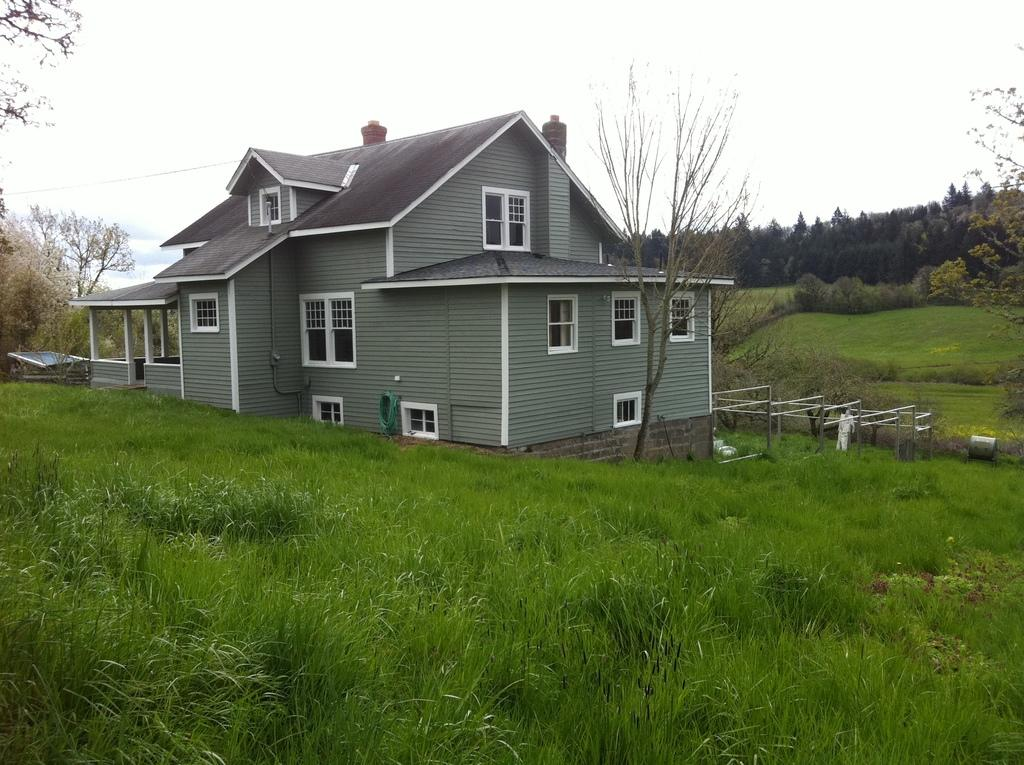What is the main structure visible in the foreground of the image? There is a house in the foreground of the image. What type of vegetation surrounds the house? There is grass around the house. What can be seen on the left side of the image? There are trees on the left side of the image. What is present on both the left and right sides of the image? There are trees and grass on both sides of the image. What is visible at the top of the image? The sky is visible at the top of the image. What type of brass instrument is being played by the trees in the image? There are no brass instruments or people playing them in the image; it features a house surrounded by trees and grass. 